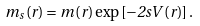<formula> <loc_0><loc_0><loc_500><loc_500>m _ { s } \left ( r \right ) = m \left ( r \right ) \exp \left [ - 2 s V \left ( r \right ) \right ] .</formula> 